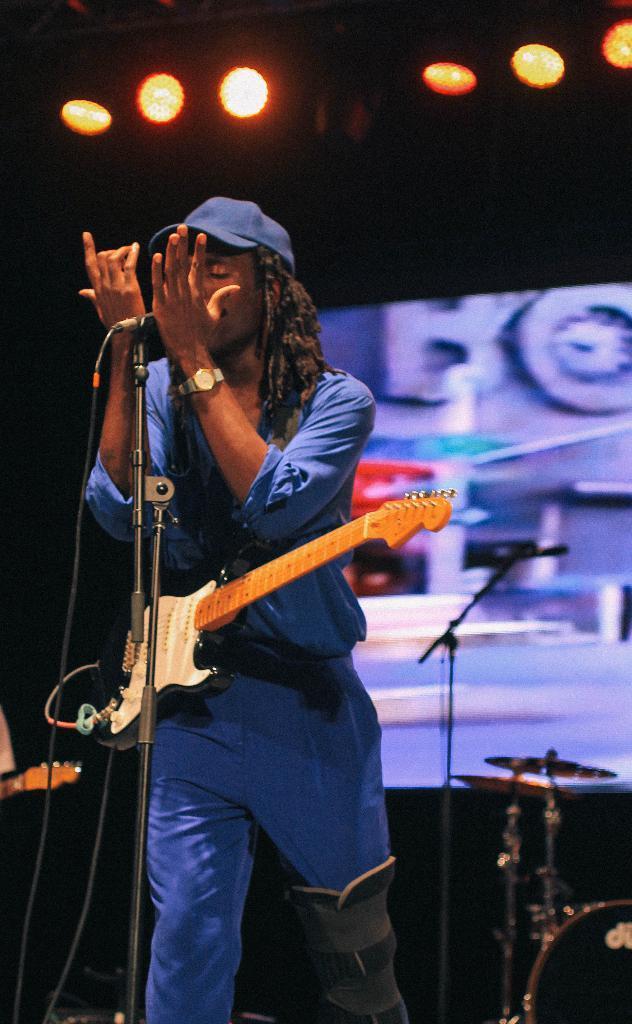How would you summarize this image in a sentence or two? This image is taken in a concert. In the middle of the image there is a man standing holding a guitar and a mic in his hands. In the right side of the image there are few musical instruments and a mic. At the background there is a screen and the lights. 